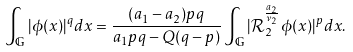<formula> <loc_0><loc_0><loc_500><loc_500>\int _ { \mathbb { G } } | \phi ( x ) | ^ { q } d x = \frac { ( a _ { 1 } - a _ { 2 } ) p q } { a _ { 1 } p q - Q ( q - p ) } \int _ { \mathbb { G } } | \mathcal { R } _ { 2 } ^ { \frac { a _ { 2 } } { \nu _ { 2 } } } \phi ( x ) | ^ { p } d x .</formula> 